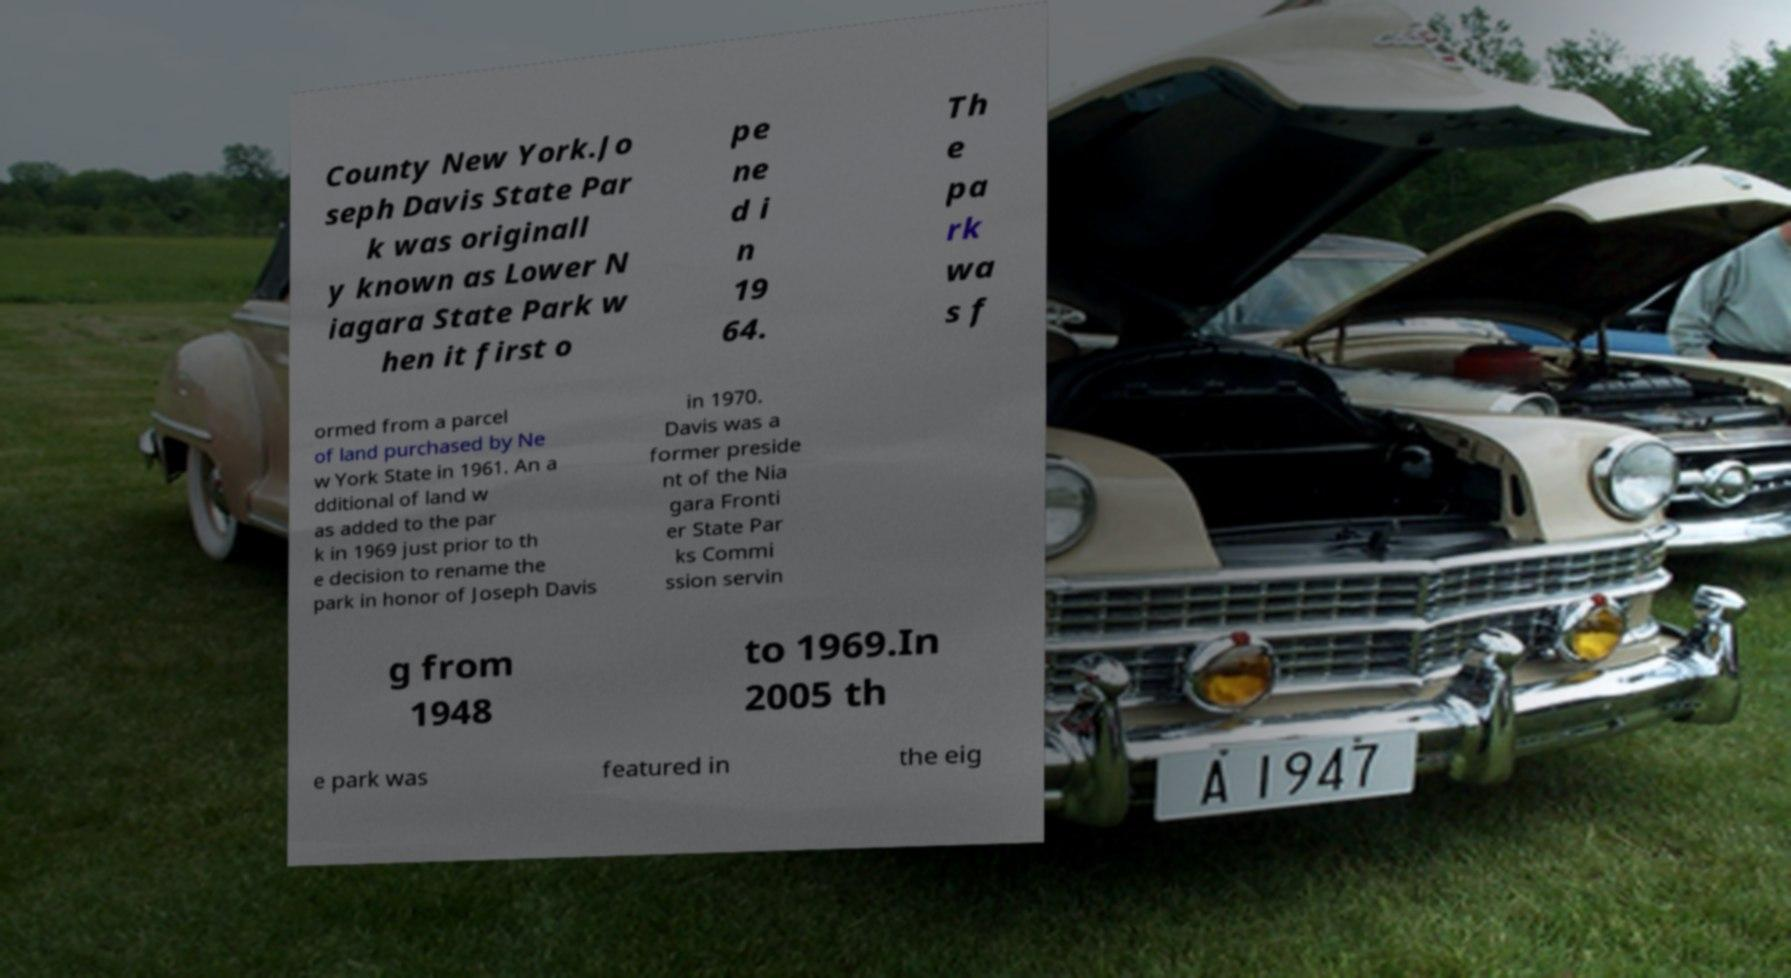Can you read and provide the text displayed in the image?This photo seems to have some interesting text. Can you extract and type it out for me? County New York.Jo seph Davis State Par k was originall y known as Lower N iagara State Park w hen it first o pe ne d i n 19 64. Th e pa rk wa s f ormed from a parcel of land purchased by Ne w York State in 1961. An a dditional of land w as added to the par k in 1969 just prior to th e decision to rename the park in honor of Joseph Davis in 1970. Davis was a former preside nt of the Nia gara Fronti er State Par ks Commi ssion servin g from 1948 to 1969.In 2005 th e park was featured in the eig 